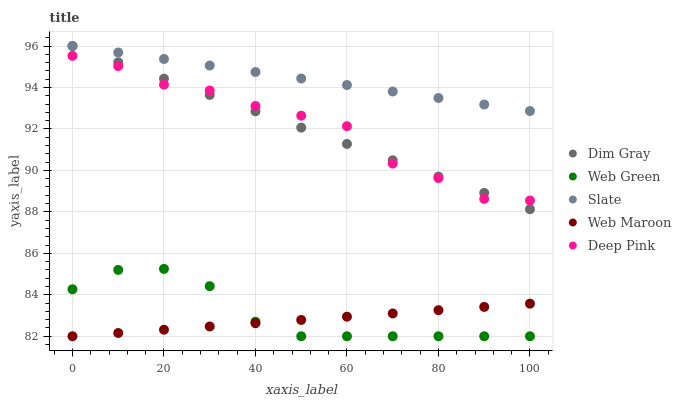Does Web Maroon have the minimum area under the curve?
Answer yes or no. Yes. Does Slate have the maximum area under the curve?
Answer yes or no. Yes. Does Dim Gray have the minimum area under the curve?
Answer yes or no. No. Does Dim Gray have the maximum area under the curve?
Answer yes or no. No. Is Web Maroon the smoothest?
Answer yes or no. Yes. Is Deep Pink the roughest?
Answer yes or no. Yes. Is Dim Gray the smoothest?
Answer yes or no. No. Is Dim Gray the roughest?
Answer yes or no. No. Does Web Maroon have the lowest value?
Answer yes or no. Yes. Does Dim Gray have the lowest value?
Answer yes or no. No. Does Dim Gray have the highest value?
Answer yes or no. Yes. Does Web Maroon have the highest value?
Answer yes or no. No. Is Web Maroon less than Slate?
Answer yes or no. Yes. Is Slate greater than Web Green?
Answer yes or no. Yes. Does Deep Pink intersect Dim Gray?
Answer yes or no. Yes. Is Deep Pink less than Dim Gray?
Answer yes or no. No. Is Deep Pink greater than Dim Gray?
Answer yes or no. No. Does Web Maroon intersect Slate?
Answer yes or no. No. 